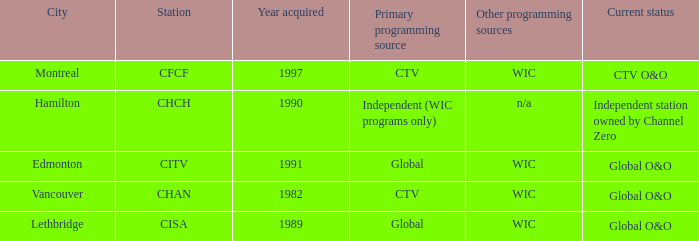Which station is located in edmonton CITV. 